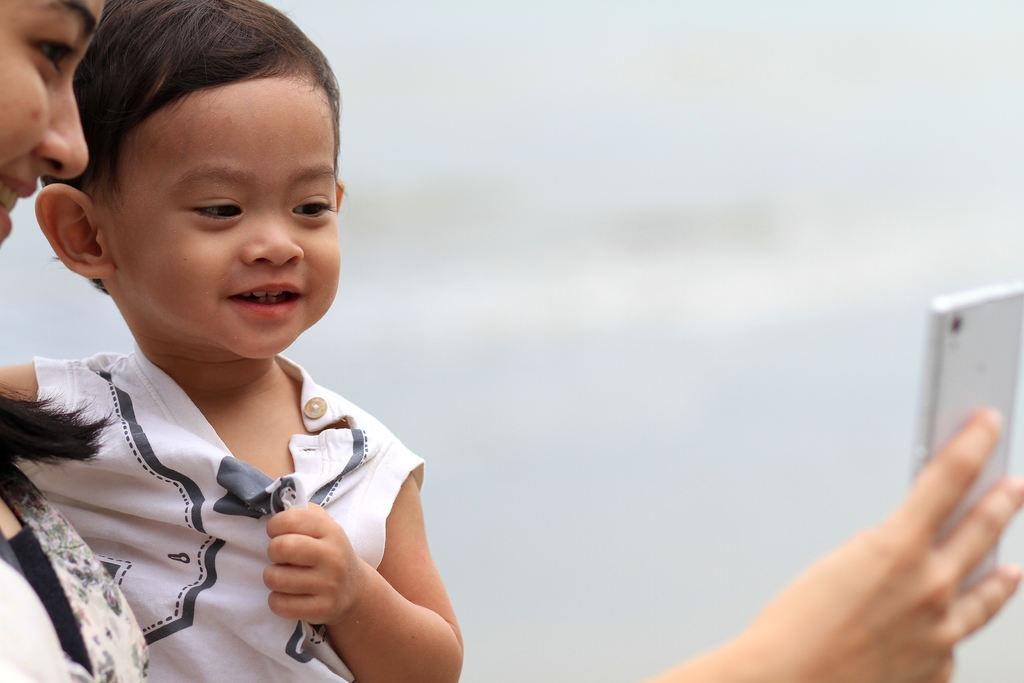How many people are present in the image? There are two people in the image. What is one person doing in the image? One person is holding a mobile in the image. What type of government is depicted in the image? There is no depiction of a government in the image; it features two people, one of whom is holding a mobile. What type of toy is visible in the image? There is no toy present in the image. 